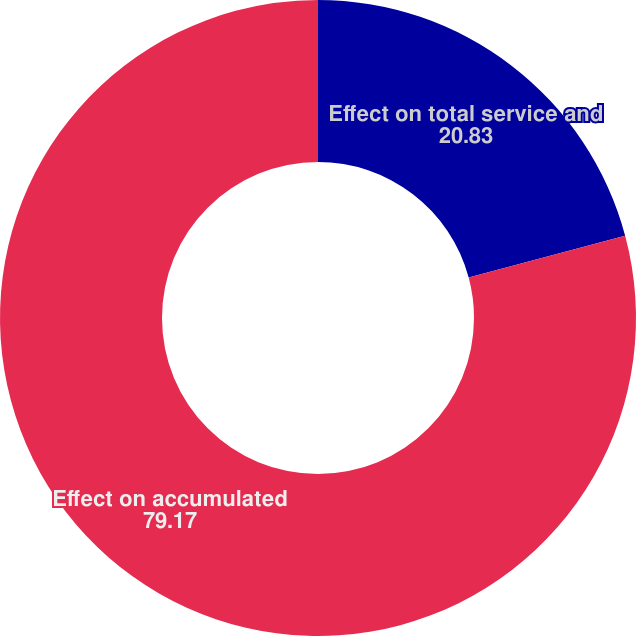Convert chart to OTSL. <chart><loc_0><loc_0><loc_500><loc_500><pie_chart><fcel>Effect on total service and<fcel>Effect on accumulated<nl><fcel>20.83%<fcel>79.17%<nl></chart> 